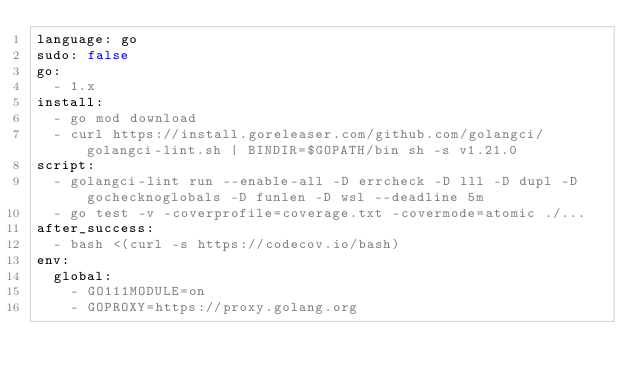<code> <loc_0><loc_0><loc_500><loc_500><_YAML_>language: go
sudo: false
go:
  - 1.x
install:
  - go mod download
  - curl https://install.goreleaser.com/github.com/golangci/golangci-lint.sh | BINDIR=$GOPATH/bin sh -s v1.21.0
script:
  - golangci-lint run --enable-all -D errcheck -D lll -D dupl -D gochecknoglobals -D funlen -D wsl --deadline 5m
  - go test -v -coverprofile=coverage.txt -covermode=atomic ./...
after_success:
  - bash <(curl -s https://codecov.io/bash)
env:
  global:
    - GO111MODULE=on
    - GOPROXY=https://proxy.golang.org
</code> 